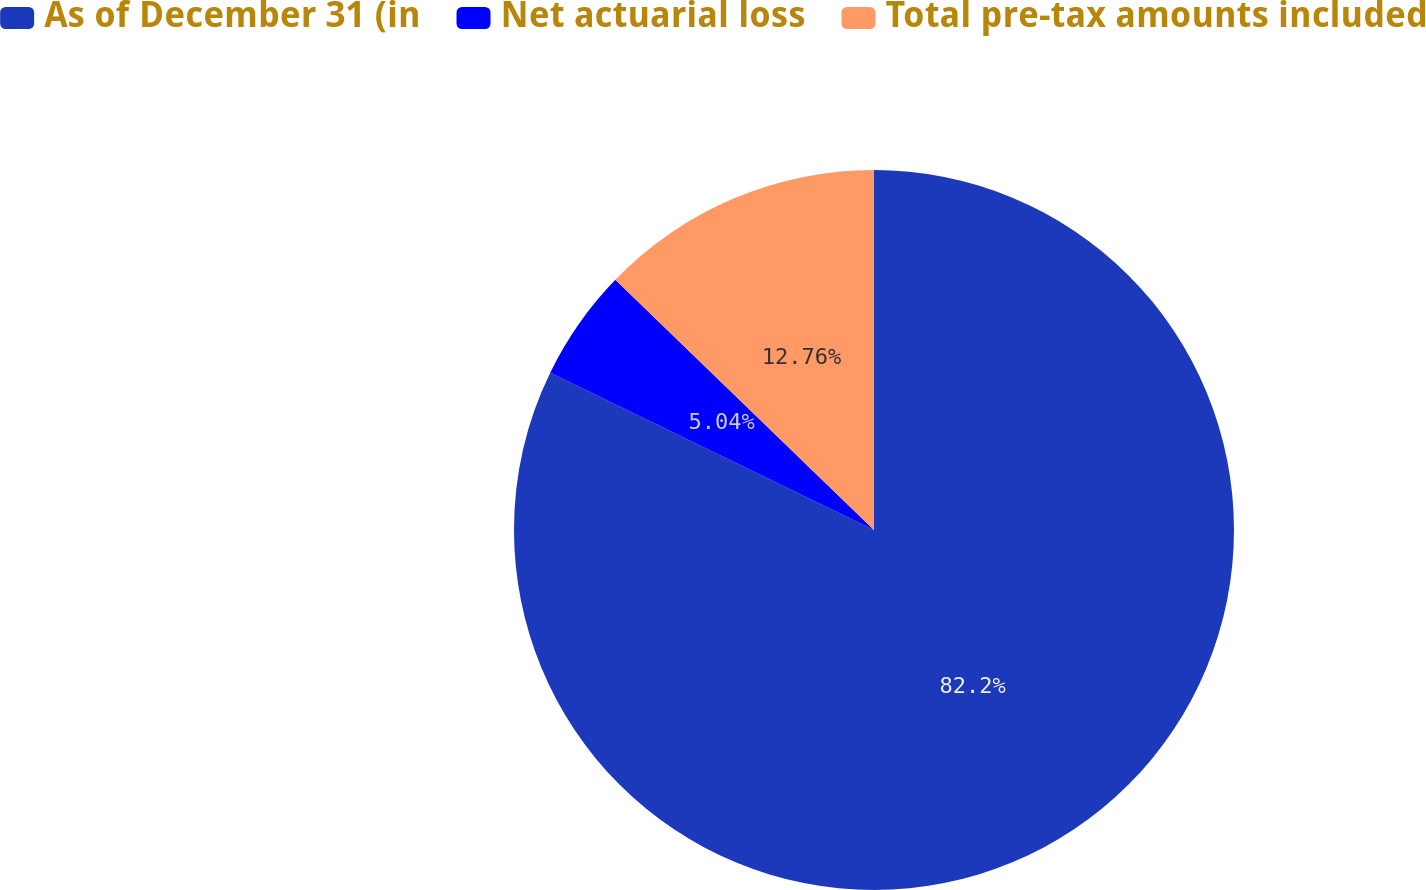<chart> <loc_0><loc_0><loc_500><loc_500><pie_chart><fcel>As of December 31 (in<fcel>Net actuarial loss<fcel>Total pre-tax amounts included<nl><fcel>82.2%<fcel>5.04%<fcel>12.76%<nl></chart> 